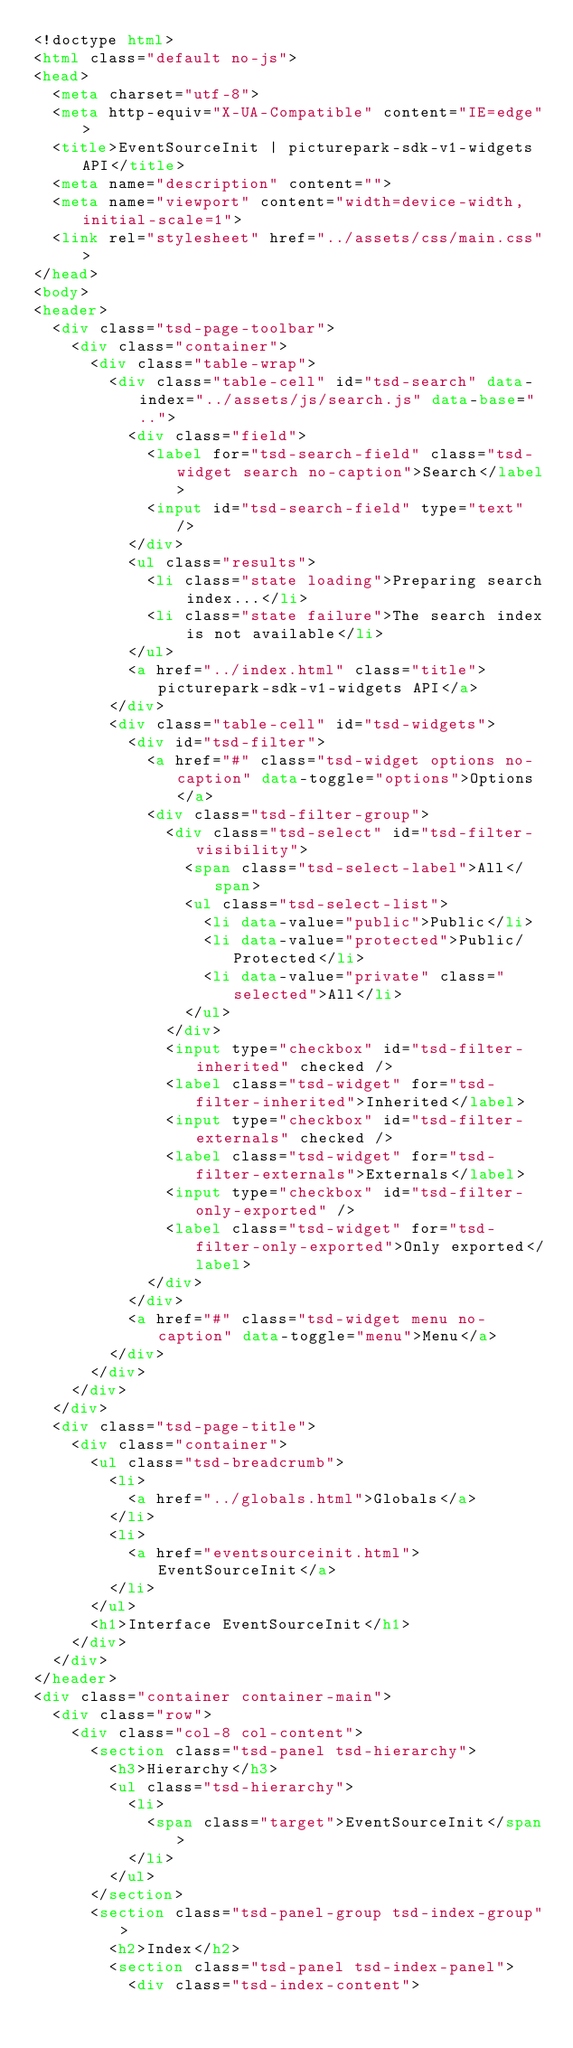Convert code to text. <code><loc_0><loc_0><loc_500><loc_500><_HTML_><!doctype html>
<html class="default no-js">
<head>
	<meta charset="utf-8">
	<meta http-equiv="X-UA-Compatible" content="IE=edge">
	<title>EventSourceInit | picturepark-sdk-v1-widgets API</title>
	<meta name="description" content="">
	<meta name="viewport" content="width=device-width, initial-scale=1">
	<link rel="stylesheet" href="../assets/css/main.css">
</head>
<body>
<header>
	<div class="tsd-page-toolbar">
		<div class="container">
			<div class="table-wrap">
				<div class="table-cell" id="tsd-search" data-index="../assets/js/search.js" data-base="..">
					<div class="field">
						<label for="tsd-search-field" class="tsd-widget search no-caption">Search</label>
						<input id="tsd-search-field" type="text" />
					</div>
					<ul class="results">
						<li class="state loading">Preparing search index...</li>
						<li class="state failure">The search index is not available</li>
					</ul>
					<a href="../index.html" class="title">picturepark-sdk-v1-widgets API</a>
				</div>
				<div class="table-cell" id="tsd-widgets">
					<div id="tsd-filter">
						<a href="#" class="tsd-widget options no-caption" data-toggle="options">Options</a>
						<div class="tsd-filter-group">
							<div class="tsd-select" id="tsd-filter-visibility">
								<span class="tsd-select-label">All</span>
								<ul class="tsd-select-list">
									<li data-value="public">Public</li>
									<li data-value="protected">Public/Protected</li>
									<li data-value="private" class="selected">All</li>
								</ul>
							</div>
							<input type="checkbox" id="tsd-filter-inherited" checked />
							<label class="tsd-widget" for="tsd-filter-inherited">Inherited</label>
							<input type="checkbox" id="tsd-filter-externals" checked />
							<label class="tsd-widget" for="tsd-filter-externals">Externals</label>
							<input type="checkbox" id="tsd-filter-only-exported" />
							<label class="tsd-widget" for="tsd-filter-only-exported">Only exported</label>
						</div>
					</div>
					<a href="#" class="tsd-widget menu no-caption" data-toggle="menu">Menu</a>
				</div>
			</div>
		</div>
	</div>
	<div class="tsd-page-title">
		<div class="container">
			<ul class="tsd-breadcrumb">
				<li>
					<a href="../globals.html">Globals</a>
				</li>
				<li>
					<a href="eventsourceinit.html">EventSourceInit</a>
				</li>
			</ul>
			<h1>Interface EventSourceInit</h1>
		</div>
	</div>
</header>
<div class="container container-main">
	<div class="row">
		<div class="col-8 col-content">
			<section class="tsd-panel tsd-hierarchy">
				<h3>Hierarchy</h3>
				<ul class="tsd-hierarchy">
					<li>
						<span class="target">EventSourceInit</span>
					</li>
				</ul>
			</section>
			<section class="tsd-panel-group tsd-index-group">
				<h2>Index</h2>
				<section class="tsd-panel tsd-index-panel">
					<div class="tsd-index-content"></code> 